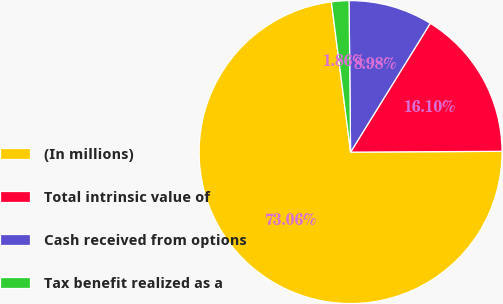Convert chart. <chart><loc_0><loc_0><loc_500><loc_500><pie_chart><fcel>(In millions)<fcel>Total intrinsic value of<fcel>Cash received from options<fcel>Tax benefit realized as a<nl><fcel>73.07%<fcel>16.1%<fcel>8.98%<fcel>1.86%<nl></chart> 